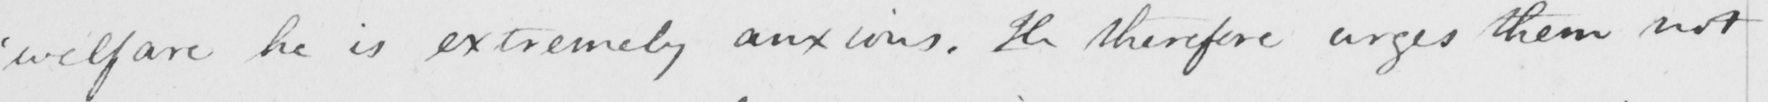What text is written in this handwritten line? ' welfare he is extremely anxious . He therefore urges them not 